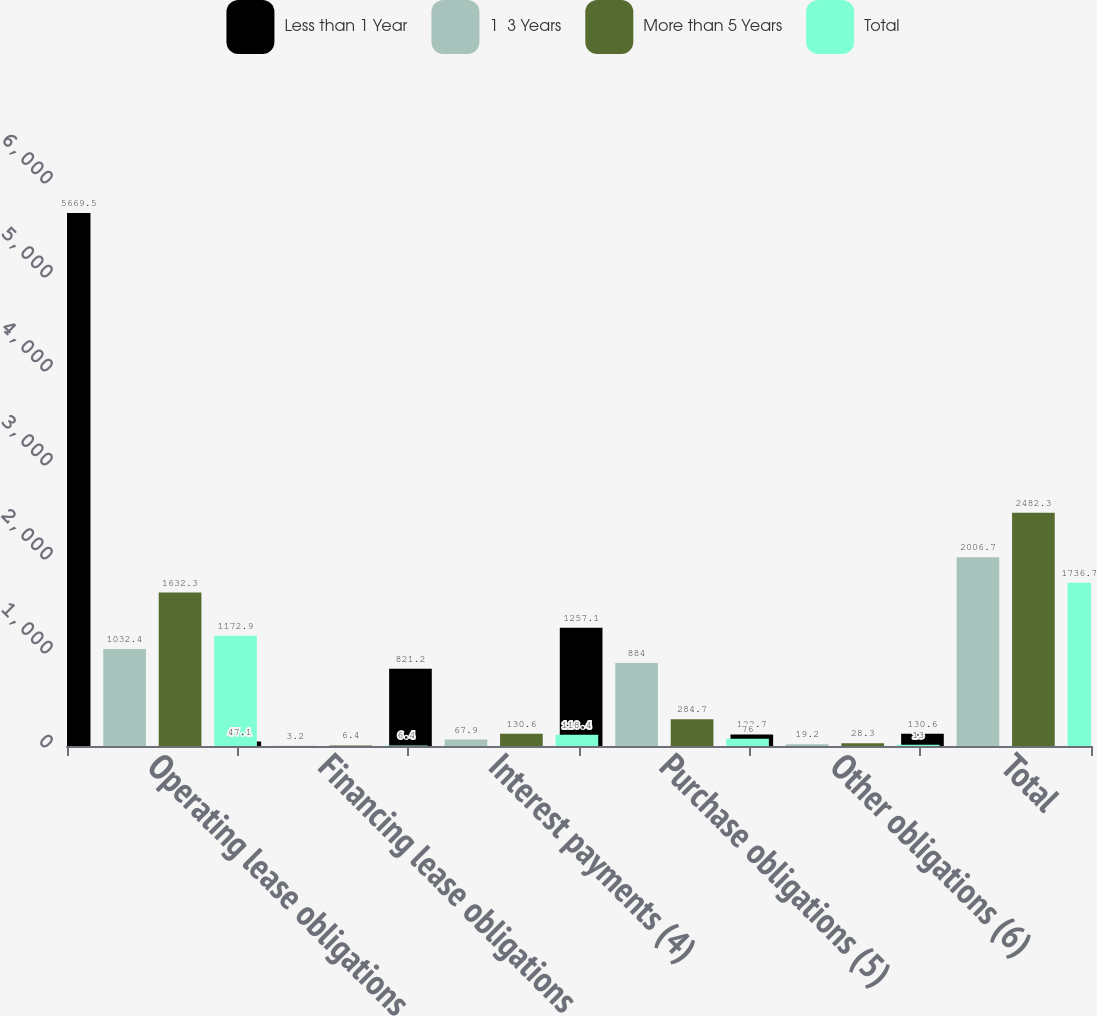<chart> <loc_0><loc_0><loc_500><loc_500><stacked_bar_chart><ecel><fcel>Operating lease obligations<fcel>Financing lease obligations<fcel>Interest payments (4)<fcel>Purchase obligations (5)<fcel>Other obligations (6)<fcel>Total<nl><fcel>Less than 1 Year<fcel>5669.5<fcel>47.1<fcel>821.2<fcel>1257.1<fcel>122.7<fcel>130.6<nl><fcel>1  3 Years<fcel>1032.4<fcel>3.2<fcel>67.9<fcel>884<fcel>19.2<fcel>2006.7<nl><fcel>More than 5 Years<fcel>1632.3<fcel>6.4<fcel>130.6<fcel>284.7<fcel>28.3<fcel>2482.3<nl><fcel>Total<fcel>1172.9<fcel>6.4<fcel>118.4<fcel>76<fcel>13<fcel>1736.7<nl></chart> 